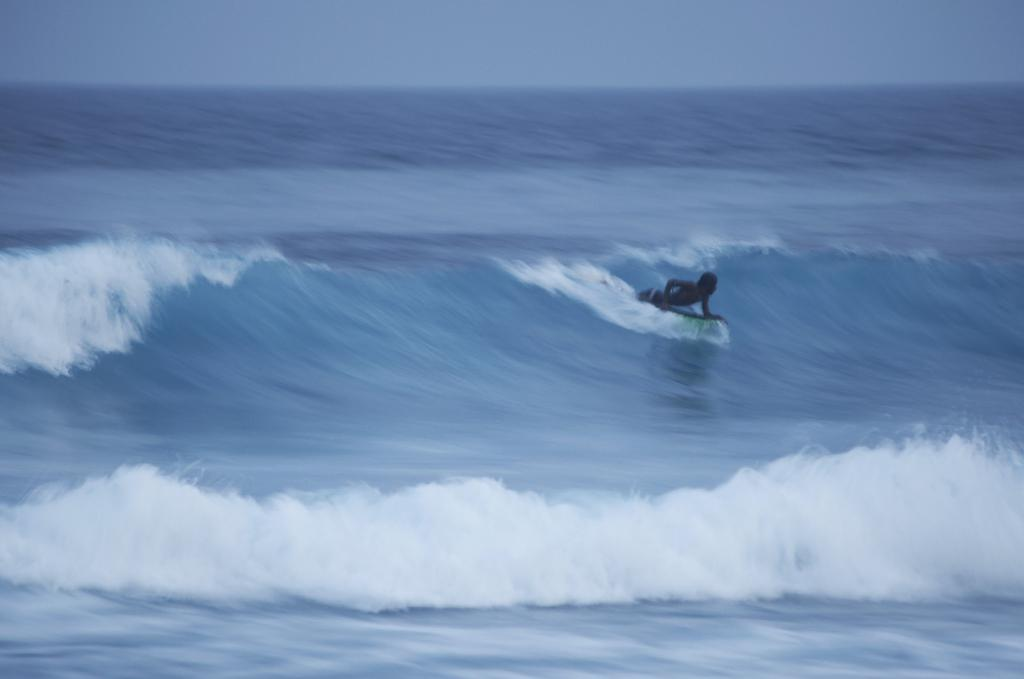What is the main subject of the image? There is a person in the image. What is the person doing in the image? The person is surfing on a surfboard. Where is the surfboard located in the image? The surfboard is on the water. What can be seen in the background of the image? There is a sky visible in the background of the image. What type of hammer is being used by the person in the image? There is no hammer present in the image; the person is surfing on a surfboard. What effect does the tongue have on the surfboard in the image? There is no tongue present in the image, and the surfboard is not affected by any tongue. 